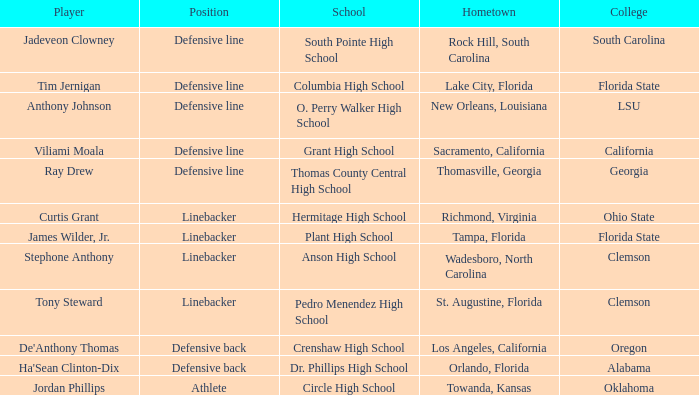For which college does jordan phillips participate in sports? Oklahoma. Would you be able to parse every entry in this table? {'header': ['Player', 'Position', 'School', 'Hometown', 'College'], 'rows': [['Jadeveon Clowney', 'Defensive line', 'South Pointe High School', 'Rock Hill, South Carolina', 'South Carolina'], ['Tim Jernigan', 'Defensive line', 'Columbia High School', 'Lake City, Florida', 'Florida State'], ['Anthony Johnson', 'Defensive line', 'O. Perry Walker High School', 'New Orleans, Louisiana', 'LSU'], ['Viliami Moala', 'Defensive line', 'Grant High School', 'Sacramento, California', 'California'], ['Ray Drew', 'Defensive line', 'Thomas County Central High School', 'Thomasville, Georgia', 'Georgia'], ['Curtis Grant', 'Linebacker', 'Hermitage High School', 'Richmond, Virginia', 'Ohio State'], ['James Wilder, Jr.', 'Linebacker', 'Plant High School', 'Tampa, Florida', 'Florida State'], ['Stephone Anthony', 'Linebacker', 'Anson High School', 'Wadesboro, North Carolina', 'Clemson'], ['Tony Steward', 'Linebacker', 'Pedro Menendez High School', 'St. Augustine, Florida', 'Clemson'], ["De'Anthony Thomas", 'Defensive back', 'Crenshaw High School', 'Los Angeles, California', 'Oregon'], ["Ha'Sean Clinton-Dix", 'Defensive back', 'Dr. Phillips High School', 'Orlando, Florida', 'Alabama'], ['Jordan Phillips', 'Athlete', 'Circle High School', 'Towanda, Kansas', 'Oklahoma']]} 